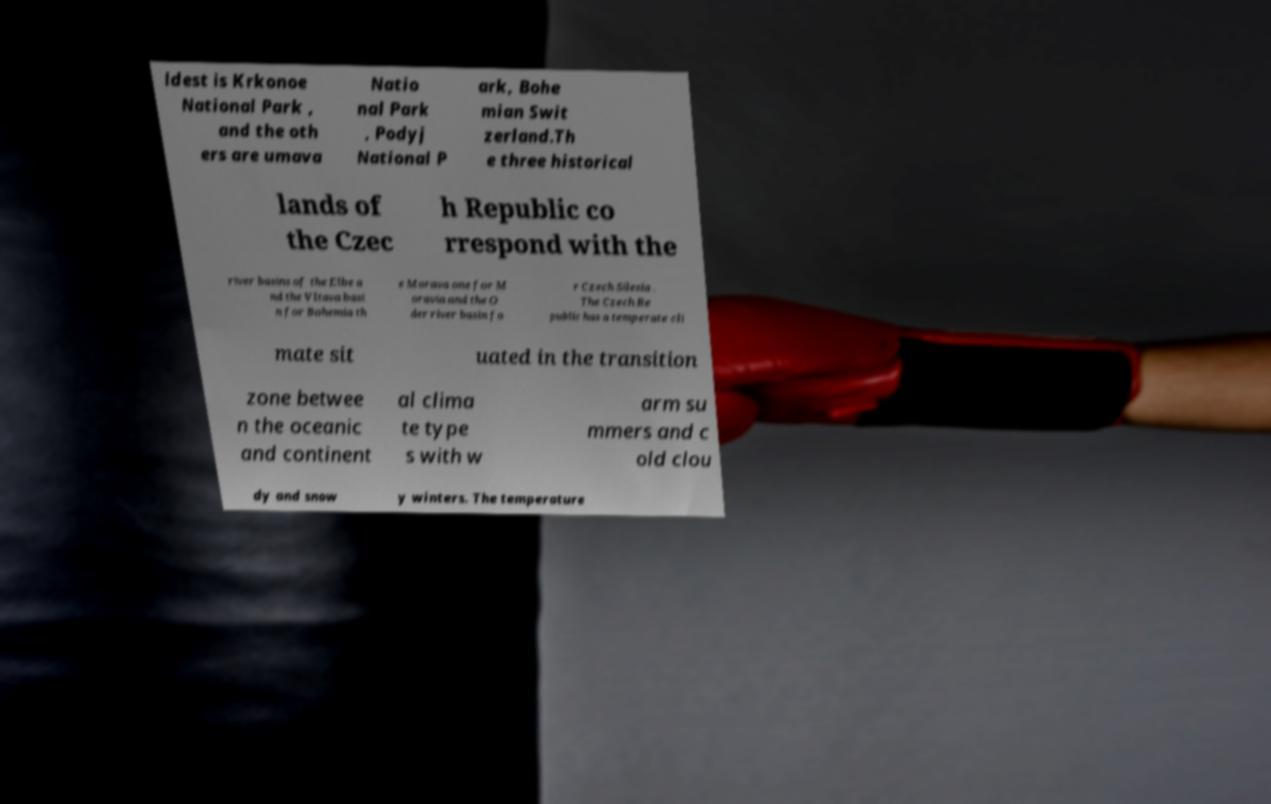Please identify and transcribe the text found in this image. ldest is Krkonoe National Park , and the oth ers are umava Natio nal Park , Podyj National P ark, Bohe mian Swit zerland.Th e three historical lands of the Czec h Republic co rrespond with the river basins of the Elbe a nd the Vltava basi n for Bohemia th e Morava one for M oravia and the O der river basin fo r Czech Silesia . The Czech Re public has a temperate cli mate sit uated in the transition zone betwee n the oceanic and continent al clima te type s with w arm su mmers and c old clou dy and snow y winters. The temperature 